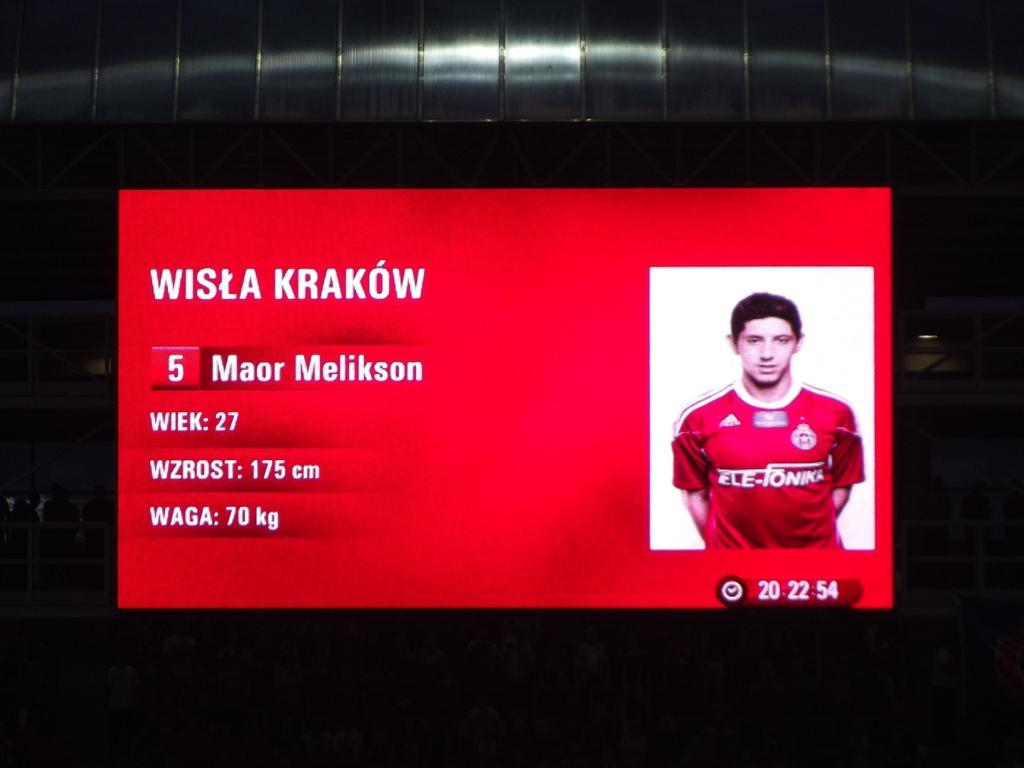<image>
Write a terse but informative summary of the picture. Red card which has a picture of a man and says Wisla Krakow. 